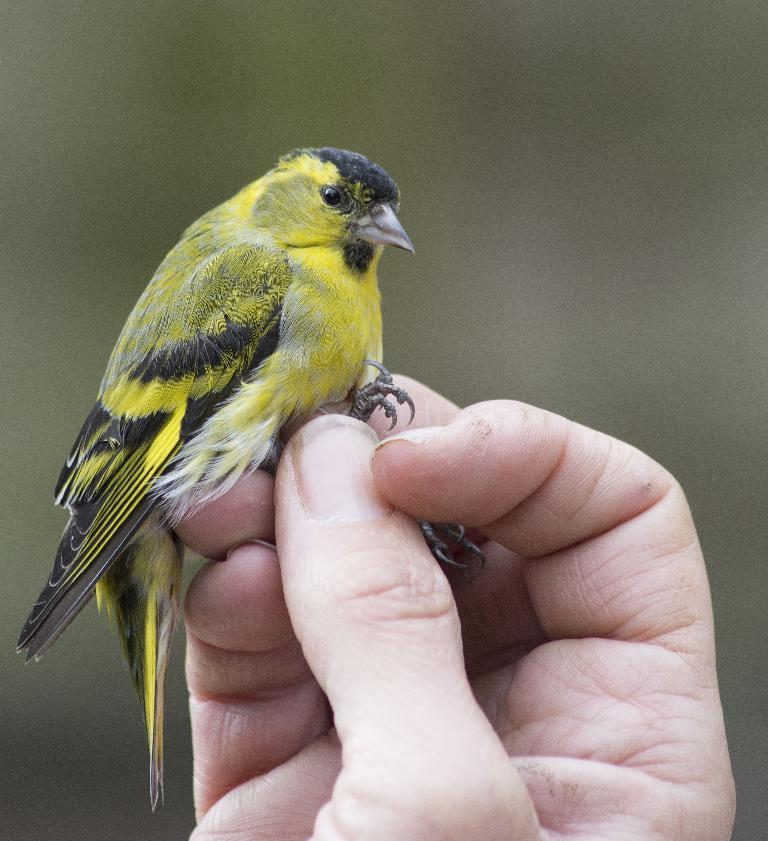What can be seen in the foreground of the image? There is a person's hand visible in the foreground of the image. What is the person holding in the image? The person is holding a bird. Can you describe the background of the image? The background of the image is blurred. What type of house can be seen in the background of the image? There is no house visible in the background of the image; it is blurred. 